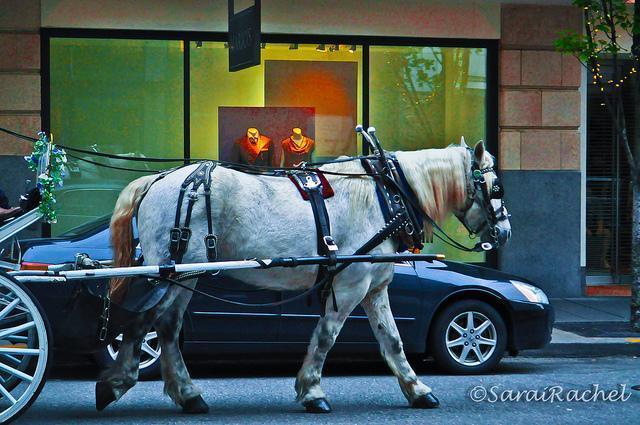How many cars are here?
Give a very brief answer. 1. How many cars are visible?
Give a very brief answer. 1. 